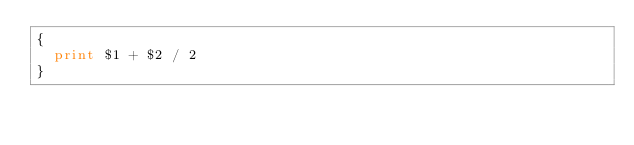<code> <loc_0><loc_0><loc_500><loc_500><_Awk_>{
  print $1 + $2 / 2
}</code> 